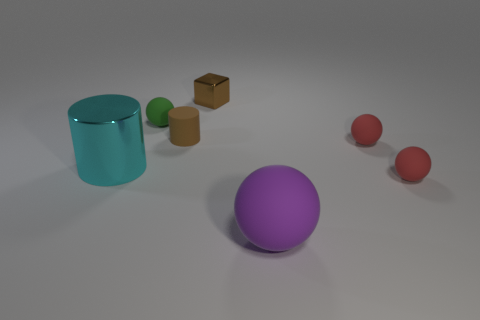Subtract all small spheres. How many spheres are left? 1 Add 3 green matte objects. How many objects exist? 10 Subtract all yellow spheres. Subtract all red cubes. How many spheres are left? 4 Subtract all cubes. How many objects are left? 6 Subtract all large rubber things. Subtract all purple matte spheres. How many objects are left? 5 Add 5 shiny objects. How many shiny objects are left? 7 Add 5 large spheres. How many large spheres exist? 6 Subtract 1 green spheres. How many objects are left? 6 